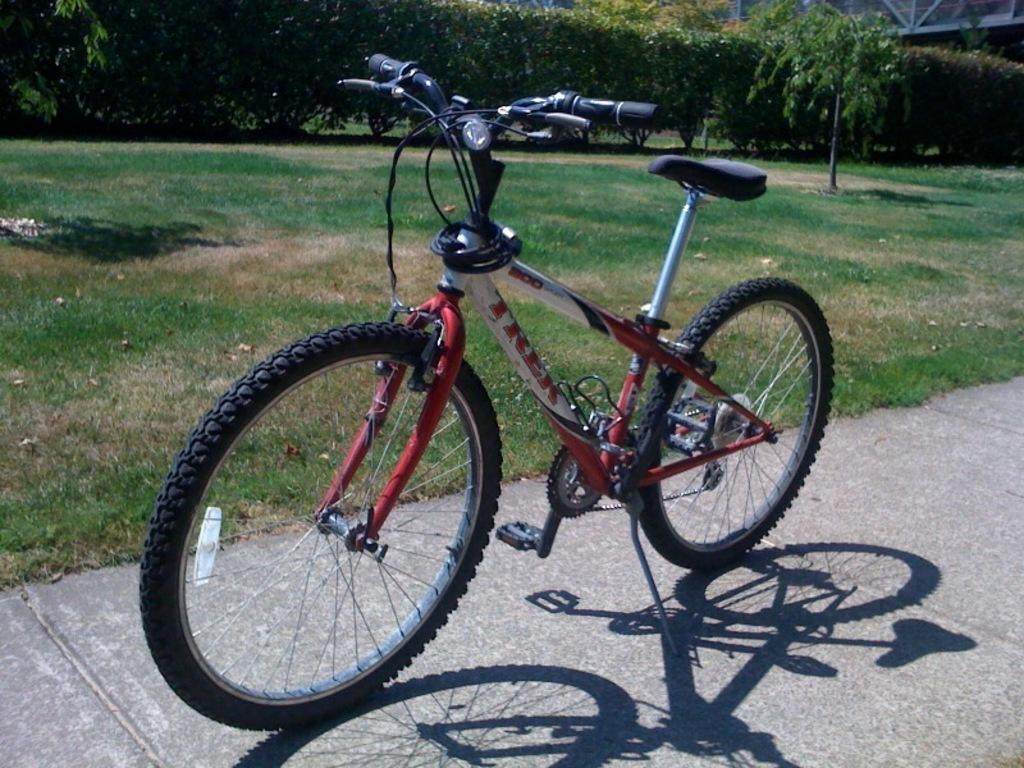How would you summarize this image in a sentence or two? This picture is highlighted with a bicycle. Here we can see a shadow of the bicycle. Behind this there is a grass. On the background of the picture we can see few trees. This is a pole. This is the path or road. 